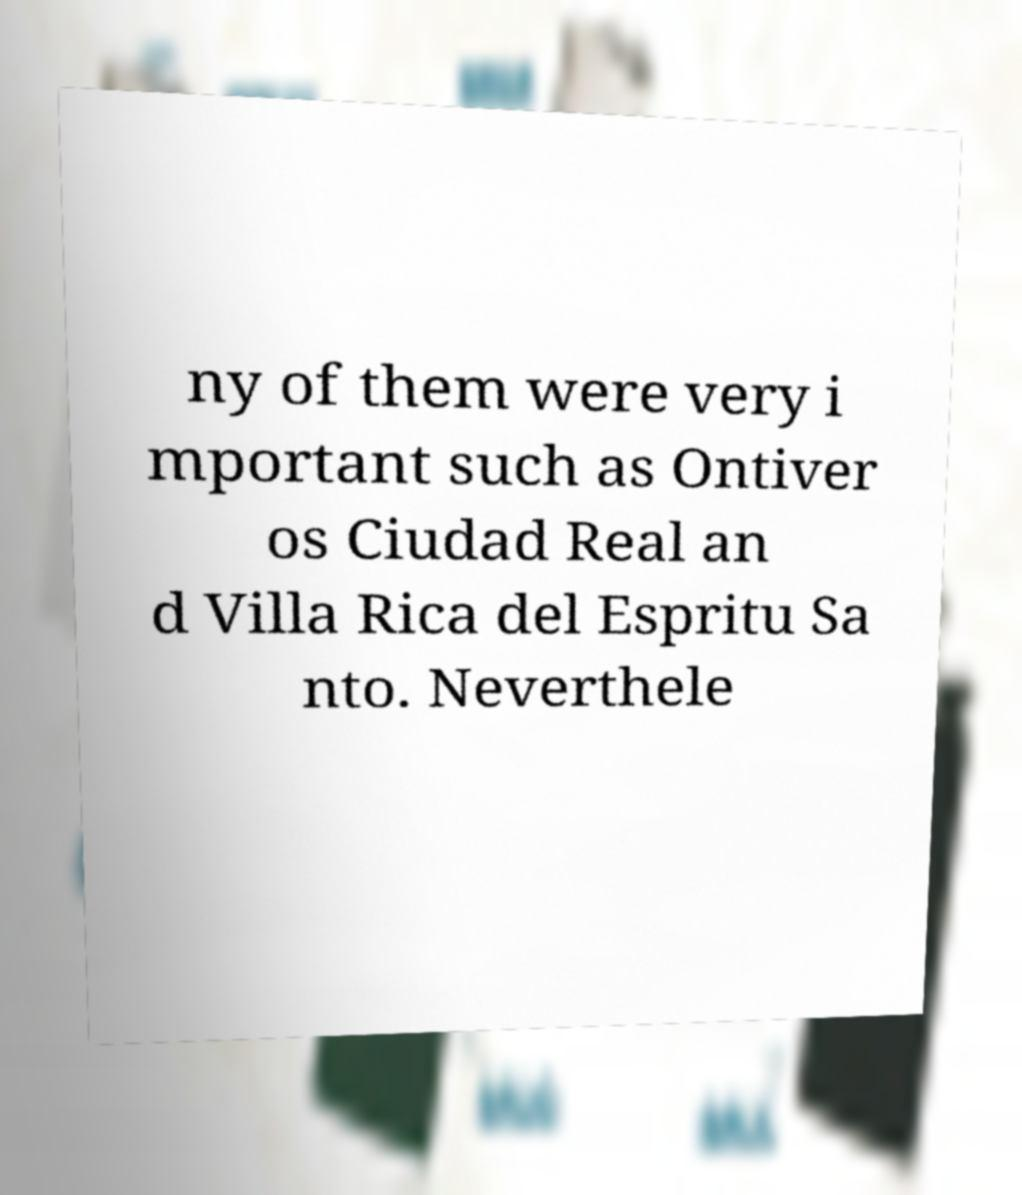Could you assist in decoding the text presented in this image and type it out clearly? ny of them were very i mportant such as Ontiver os Ciudad Real an d Villa Rica del Espritu Sa nto. Neverthele 